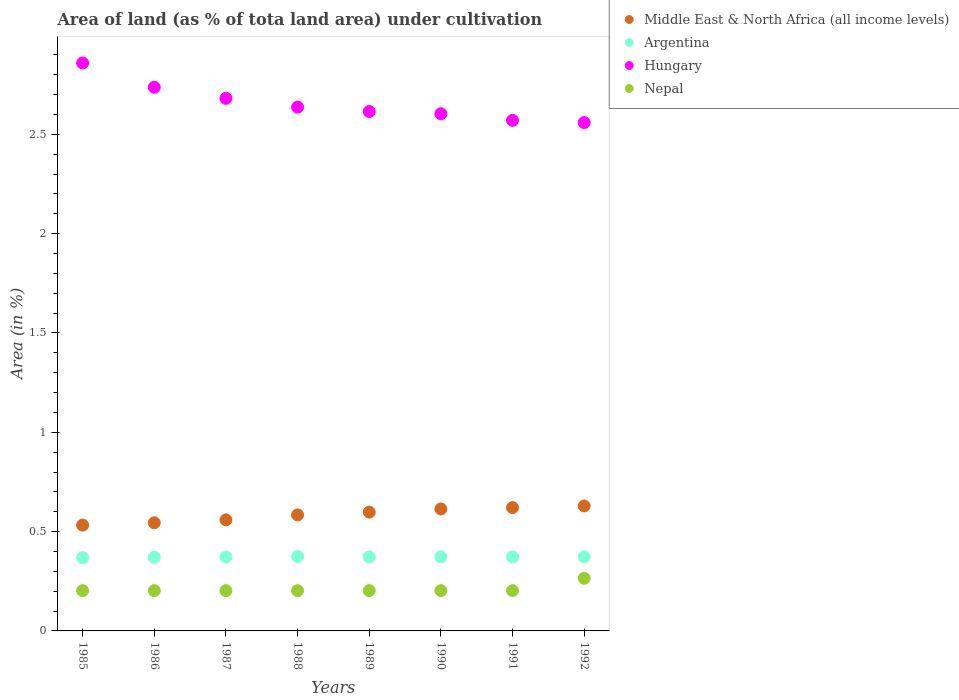Is the number of dotlines equal to the number of legend labels?
Provide a succinct answer. Yes. What is the percentage of land under cultivation in Middle East & North Africa (all income levels) in 1986?
Offer a terse response. 0.54. Across all years, what is the maximum percentage of land under cultivation in Hungary?
Keep it short and to the point. 2.86. Across all years, what is the minimum percentage of land under cultivation in Nepal?
Provide a succinct answer. 0.2. What is the total percentage of land under cultivation in Middle East & North Africa (all income levels) in the graph?
Ensure brevity in your answer.  4.68. What is the difference between the percentage of land under cultivation in Argentina in 1986 and that in 1987?
Offer a very short reply. -0. What is the difference between the percentage of land under cultivation in Nepal in 1991 and the percentage of land under cultivation in Argentina in 1987?
Provide a succinct answer. -0.17. What is the average percentage of land under cultivation in Hungary per year?
Make the answer very short. 2.66. In the year 1990, what is the difference between the percentage of land under cultivation in Nepal and percentage of land under cultivation in Argentina?
Provide a succinct answer. -0.17. In how many years, is the percentage of land under cultivation in Middle East & North Africa (all income levels) greater than 2.2 %?
Give a very brief answer. 0. What is the difference between the highest and the second highest percentage of land under cultivation in Hungary?
Give a very brief answer. 0.12. What is the difference between the highest and the lowest percentage of land under cultivation in Argentina?
Offer a terse response. 0.01. Does the percentage of land under cultivation in Nepal monotonically increase over the years?
Your answer should be very brief. No. Is the percentage of land under cultivation in Argentina strictly greater than the percentage of land under cultivation in Hungary over the years?
Offer a very short reply. No. How many dotlines are there?
Offer a very short reply. 4. How many years are there in the graph?
Your response must be concise. 8. Are the values on the major ticks of Y-axis written in scientific E-notation?
Your response must be concise. No. Does the graph contain any zero values?
Provide a succinct answer. No. How many legend labels are there?
Your response must be concise. 4. What is the title of the graph?
Your answer should be compact. Area of land (as % of tota land area) under cultivation. What is the label or title of the Y-axis?
Give a very brief answer. Area (in %). What is the Area (in %) in Middle East & North Africa (all income levels) in 1985?
Give a very brief answer. 0.53. What is the Area (in %) in Argentina in 1985?
Provide a succinct answer. 0.37. What is the Area (in %) in Hungary in 1985?
Your answer should be compact. 2.86. What is the Area (in %) in Nepal in 1985?
Provide a succinct answer. 0.2. What is the Area (in %) of Middle East & North Africa (all income levels) in 1986?
Your answer should be compact. 0.54. What is the Area (in %) in Argentina in 1986?
Offer a very short reply. 0.37. What is the Area (in %) in Hungary in 1986?
Provide a succinct answer. 2.74. What is the Area (in %) in Nepal in 1986?
Your answer should be very brief. 0.2. What is the Area (in %) in Middle East & North Africa (all income levels) in 1987?
Ensure brevity in your answer.  0.56. What is the Area (in %) of Argentina in 1987?
Ensure brevity in your answer.  0.37. What is the Area (in %) in Hungary in 1987?
Give a very brief answer. 2.68. What is the Area (in %) of Nepal in 1987?
Your answer should be very brief. 0.2. What is the Area (in %) of Middle East & North Africa (all income levels) in 1988?
Your answer should be compact. 0.58. What is the Area (in %) in Argentina in 1988?
Make the answer very short. 0.37. What is the Area (in %) in Hungary in 1988?
Offer a terse response. 2.64. What is the Area (in %) in Nepal in 1988?
Provide a short and direct response. 0.2. What is the Area (in %) in Middle East & North Africa (all income levels) in 1989?
Offer a very short reply. 0.6. What is the Area (in %) of Argentina in 1989?
Your answer should be very brief. 0.37. What is the Area (in %) of Hungary in 1989?
Your answer should be compact. 2.61. What is the Area (in %) in Nepal in 1989?
Offer a terse response. 0.2. What is the Area (in %) in Middle East & North Africa (all income levels) in 1990?
Keep it short and to the point. 0.61. What is the Area (in %) of Argentina in 1990?
Ensure brevity in your answer.  0.37. What is the Area (in %) of Hungary in 1990?
Your answer should be very brief. 2.6. What is the Area (in %) in Nepal in 1990?
Offer a terse response. 0.2. What is the Area (in %) in Middle East & North Africa (all income levels) in 1991?
Offer a very short reply. 0.62. What is the Area (in %) in Argentina in 1991?
Offer a very short reply. 0.37. What is the Area (in %) of Hungary in 1991?
Your answer should be very brief. 2.57. What is the Area (in %) of Nepal in 1991?
Ensure brevity in your answer.  0.2. What is the Area (in %) of Middle East & North Africa (all income levels) in 1992?
Offer a very short reply. 0.63. What is the Area (in %) in Argentina in 1992?
Provide a succinct answer. 0.37. What is the Area (in %) of Hungary in 1992?
Your answer should be very brief. 2.56. What is the Area (in %) in Nepal in 1992?
Give a very brief answer. 0.27. Across all years, what is the maximum Area (in %) of Middle East & North Africa (all income levels)?
Offer a terse response. 0.63. Across all years, what is the maximum Area (in %) in Argentina?
Your response must be concise. 0.37. Across all years, what is the maximum Area (in %) in Hungary?
Your answer should be compact. 2.86. Across all years, what is the maximum Area (in %) in Nepal?
Your response must be concise. 0.27. Across all years, what is the minimum Area (in %) of Middle East & North Africa (all income levels)?
Ensure brevity in your answer.  0.53. Across all years, what is the minimum Area (in %) in Argentina?
Your answer should be compact. 0.37. Across all years, what is the minimum Area (in %) of Hungary?
Provide a short and direct response. 2.56. Across all years, what is the minimum Area (in %) of Nepal?
Your answer should be compact. 0.2. What is the total Area (in %) of Middle East & North Africa (all income levels) in the graph?
Your answer should be compact. 4.68. What is the total Area (in %) of Argentina in the graph?
Offer a terse response. 2.98. What is the total Area (in %) of Hungary in the graph?
Keep it short and to the point. 21.26. What is the total Area (in %) of Nepal in the graph?
Give a very brief answer. 1.68. What is the difference between the Area (in %) of Middle East & North Africa (all income levels) in 1985 and that in 1986?
Offer a terse response. -0.01. What is the difference between the Area (in %) of Argentina in 1985 and that in 1986?
Your answer should be compact. -0. What is the difference between the Area (in %) in Hungary in 1985 and that in 1986?
Make the answer very short. 0.12. What is the difference between the Area (in %) of Nepal in 1985 and that in 1986?
Offer a terse response. 0. What is the difference between the Area (in %) of Middle East & North Africa (all income levels) in 1985 and that in 1987?
Provide a short and direct response. -0.03. What is the difference between the Area (in %) of Argentina in 1985 and that in 1987?
Provide a succinct answer. -0. What is the difference between the Area (in %) of Hungary in 1985 and that in 1987?
Give a very brief answer. 0.18. What is the difference between the Area (in %) of Nepal in 1985 and that in 1987?
Your answer should be very brief. 0. What is the difference between the Area (in %) in Middle East & North Africa (all income levels) in 1985 and that in 1988?
Make the answer very short. -0.05. What is the difference between the Area (in %) of Argentina in 1985 and that in 1988?
Provide a short and direct response. -0.01. What is the difference between the Area (in %) in Hungary in 1985 and that in 1988?
Your response must be concise. 0.22. What is the difference between the Area (in %) in Middle East & North Africa (all income levels) in 1985 and that in 1989?
Give a very brief answer. -0.07. What is the difference between the Area (in %) of Argentina in 1985 and that in 1989?
Offer a terse response. -0. What is the difference between the Area (in %) in Hungary in 1985 and that in 1989?
Your response must be concise. 0.24. What is the difference between the Area (in %) in Nepal in 1985 and that in 1989?
Provide a succinct answer. 0. What is the difference between the Area (in %) of Middle East & North Africa (all income levels) in 1985 and that in 1990?
Your answer should be compact. -0.08. What is the difference between the Area (in %) of Argentina in 1985 and that in 1990?
Your answer should be compact. -0. What is the difference between the Area (in %) in Hungary in 1985 and that in 1990?
Offer a terse response. 0.26. What is the difference between the Area (in %) of Nepal in 1985 and that in 1990?
Make the answer very short. 0. What is the difference between the Area (in %) in Middle East & North Africa (all income levels) in 1985 and that in 1991?
Provide a succinct answer. -0.09. What is the difference between the Area (in %) in Argentina in 1985 and that in 1991?
Offer a very short reply. -0. What is the difference between the Area (in %) in Hungary in 1985 and that in 1991?
Your answer should be very brief. 0.29. What is the difference between the Area (in %) of Nepal in 1985 and that in 1991?
Give a very brief answer. 0. What is the difference between the Area (in %) of Middle East & North Africa (all income levels) in 1985 and that in 1992?
Keep it short and to the point. -0.1. What is the difference between the Area (in %) of Argentina in 1985 and that in 1992?
Give a very brief answer. -0. What is the difference between the Area (in %) in Hungary in 1985 and that in 1992?
Give a very brief answer. 0.3. What is the difference between the Area (in %) of Nepal in 1985 and that in 1992?
Your answer should be compact. -0.06. What is the difference between the Area (in %) in Middle East & North Africa (all income levels) in 1986 and that in 1987?
Make the answer very short. -0.01. What is the difference between the Area (in %) in Argentina in 1986 and that in 1987?
Ensure brevity in your answer.  -0. What is the difference between the Area (in %) in Hungary in 1986 and that in 1987?
Your response must be concise. 0.06. What is the difference between the Area (in %) in Nepal in 1986 and that in 1987?
Offer a very short reply. 0. What is the difference between the Area (in %) in Middle East & North Africa (all income levels) in 1986 and that in 1988?
Ensure brevity in your answer.  -0.04. What is the difference between the Area (in %) of Argentina in 1986 and that in 1988?
Your answer should be compact. -0. What is the difference between the Area (in %) of Hungary in 1986 and that in 1988?
Offer a very short reply. 0.1. What is the difference between the Area (in %) in Nepal in 1986 and that in 1988?
Make the answer very short. 0. What is the difference between the Area (in %) of Middle East & North Africa (all income levels) in 1986 and that in 1989?
Ensure brevity in your answer.  -0.05. What is the difference between the Area (in %) in Argentina in 1986 and that in 1989?
Keep it short and to the point. -0. What is the difference between the Area (in %) in Hungary in 1986 and that in 1989?
Offer a very short reply. 0.12. What is the difference between the Area (in %) in Middle East & North Africa (all income levels) in 1986 and that in 1990?
Ensure brevity in your answer.  -0.07. What is the difference between the Area (in %) in Argentina in 1986 and that in 1990?
Your answer should be compact. -0. What is the difference between the Area (in %) in Hungary in 1986 and that in 1990?
Provide a short and direct response. 0.13. What is the difference between the Area (in %) of Middle East & North Africa (all income levels) in 1986 and that in 1991?
Offer a terse response. -0.08. What is the difference between the Area (in %) in Argentina in 1986 and that in 1991?
Offer a terse response. -0. What is the difference between the Area (in %) of Hungary in 1986 and that in 1991?
Give a very brief answer. 0.17. What is the difference between the Area (in %) of Middle East & North Africa (all income levels) in 1986 and that in 1992?
Offer a very short reply. -0.08. What is the difference between the Area (in %) of Argentina in 1986 and that in 1992?
Ensure brevity in your answer.  -0. What is the difference between the Area (in %) in Hungary in 1986 and that in 1992?
Provide a short and direct response. 0.18. What is the difference between the Area (in %) of Nepal in 1986 and that in 1992?
Your response must be concise. -0.06. What is the difference between the Area (in %) of Middle East & North Africa (all income levels) in 1987 and that in 1988?
Ensure brevity in your answer.  -0.02. What is the difference between the Area (in %) in Argentina in 1987 and that in 1988?
Make the answer very short. -0. What is the difference between the Area (in %) of Hungary in 1987 and that in 1988?
Provide a short and direct response. 0.04. What is the difference between the Area (in %) of Middle East & North Africa (all income levels) in 1987 and that in 1989?
Your answer should be compact. -0.04. What is the difference between the Area (in %) of Argentina in 1987 and that in 1989?
Offer a very short reply. -0. What is the difference between the Area (in %) in Hungary in 1987 and that in 1989?
Provide a short and direct response. 0.07. What is the difference between the Area (in %) of Middle East & North Africa (all income levels) in 1987 and that in 1990?
Offer a very short reply. -0.05. What is the difference between the Area (in %) of Argentina in 1987 and that in 1990?
Ensure brevity in your answer.  -0. What is the difference between the Area (in %) in Hungary in 1987 and that in 1990?
Ensure brevity in your answer.  0.08. What is the difference between the Area (in %) in Middle East & North Africa (all income levels) in 1987 and that in 1991?
Provide a short and direct response. -0.06. What is the difference between the Area (in %) of Argentina in 1987 and that in 1991?
Offer a terse response. -0. What is the difference between the Area (in %) of Hungary in 1987 and that in 1991?
Offer a very short reply. 0.11. What is the difference between the Area (in %) in Nepal in 1987 and that in 1991?
Ensure brevity in your answer.  0. What is the difference between the Area (in %) in Middle East & North Africa (all income levels) in 1987 and that in 1992?
Ensure brevity in your answer.  -0.07. What is the difference between the Area (in %) of Argentina in 1987 and that in 1992?
Provide a succinct answer. -0. What is the difference between the Area (in %) of Hungary in 1987 and that in 1992?
Keep it short and to the point. 0.12. What is the difference between the Area (in %) in Nepal in 1987 and that in 1992?
Your answer should be very brief. -0.06. What is the difference between the Area (in %) in Middle East & North Africa (all income levels) in 1988 and that in 1989?
Give a very brief answer. -0.01. What is the difference between the Area (in %) in Argentina in 1988 and that in 1989?
Make the answer very short. 0. What is the difference between the Area (in %) of Hungary in 1988 and that in 1989?
Make the answer very short. 0.02. What is the difference between the Area (in %) of Nepal in 1988 and that in 1989?
Provide a short and direct response. 0. What is the difference between the Area (in %) of Middle East & North Africa (all income levels) in 1988 and that in 1990?
Your response must be concise. -0.03. What is the difference between the Area (in %) in Argentina in 1988 and that in 1990?
Your response must be concise. 0. What is the difference between the Area (in %) in Hungary in 1988 and that in 1990?
Make the answer very short. 0.03. What is the difference between the Area (in %) of Nepal in 1988 and that in 1990?
Your answer should be very brief. 0. What is the difference between the Area (in %) of Middle East & North Africa (all income levels) in 1988 and that in 1991?
Your answer should be compact. -0.04. What is the difference between the Area (in %) of Argentina in 1988 and that in 1991?
Ensure brevity in your answer.  0. What is the difference between the Area (in %) of Hungary in 1988 and that in 1991?
Your response must be concise. 0.07. What is the difference between the Area (in %) of Nepal in 1988 and that in 1991?
Provide a succinct answer. 0. What is the difference between the Area (in %) in Middle East & North Africa (all income levels) in 1988 and that in 1992?
Your answer should be very brief. -0.05. What is the difference between the Area (in %) in Argentina in 1988 and that in 1992?
Offer a very short reply. 0. What is the difference between the Area (in %) of Hungary in 1988 and that in 1992?
Keep it short and to the point. 0.08. What is the difference between the Area (in %) of Nepal in 1988 and that in 1992?
Your answer should be compact. -0.06. What is the difference between the Area (in %) of Middle East & North Africa (all income levels) in 1989 and that in 1990?
Your response must be concise. -0.02. What is the difference between the Area (in %) in Argentina in 1989 and that in 1990?
Make the answer very short. 0. What is the difference between the Area (in %) in Hungary in 1989 and that in 1990?
Offer a terse response. 0.01. What is the difference between the Area (in %) of Nepal in 1989 and that in 1990?
Make the answer very short. 0. What is the difference between the Area (in %) in Middle East & North Africa (all income levels) in 1989 and that in 1991?
Give a very brief answer. -0.02. What is the difference between the Area (in %) of Hungary in 1989 and that in 1991?
Make the answer very short. 0.04. What is the difference between the Area (in %) of Middle East & North Africa (all income levels) in 1989 and that in 1992?
Your answer should be compact. -0.03. What is the difference between the Area (in %) of Hungary in 1989 and that in 1992?
Ensure brevity in your answer.  0.06. What is the difference between the Area (in %) of Nepal in 1989 and that in 1992?
Offer a terse response. -0.06. What is the difference between the Area (in %) in Middle East & North Africa (all income levels) in 1990 and that in 1991?
Ensure brevity in your answer.  -0.01. What is the difference between the Area (in %) of Hungary in 1990 and that in 1991?
Your response must be concise. 0.03. What is the difference between the Area (in %) in Nepal in 1990 and that in 1991?
Ensure brevity in your answer.  0. What is the difference between the Area (in %) in Middle East & North Africa (all income levels) in 1990 and that in 1992?
Ensure brevity in your answer.  -0.02. What is the difference between the Area (in %) of Argentina in 1990 and that in 1992?
Offer a very short reply. 0. What is the difference between the Area (in %) of Hungary in 1990 and that in 1992?
Provide a short and direct response. 0.04. What is the difference between the Area (in %) of Nepal in 1990 and that in 1992?
Your answer should be very brief. -0.06. What is the difference between the Area (in %) of Middle East & North Africa (all income levels) in 1991 and that in 1992?
Your answer should be compact. -0.01. What is the difference between the Area (in %) of Argentina in 1991 and that in 1992?
Your response must be concise. 0. What is the difference between the Area (in %) in Hungary in 1991 and that in 1992?
Provide a succinct answer. 0.01. What is the difference between the Area (in %) in Nepal in 1991 and that in 1992?
Give a very brief answer. -0.06. What is the difference between the Area (in %) of Middle East & North Africa (all income levels) in 1985 and the Area (in %) of Argentina in 1986?
Ensure brevity in your answer.  0.16. What is the difference between the Area (in %) of Middle East & North Africa (all income levels) in 1985 and the Area (in %) of Hungary in 1986?
Ensure brevity in your answer.  -2.2. What is the difference between the Area (in %) in Middle East & North Africa (all income levels) in 1985 and the Area (in %) in Nepal in 1986?
Offer a very short reply. 0.33. What is the difference between the Area (in %) of Argentina in 1985 and the Area (in %) of Hungary in 1986?
Offer a very short reply. -2.37. What is the difference between the Area (in %) of Argentina in 1985 and the Area (in %) of Nepal in 1986?
Your answer should be very brief. 0.17. What is the difference between the Area (in %) in Hungary in 1985 and the Area (in %) in Nepal in 1986?
Give a very brief answer. 2.66. What is the difference between the Area (in %) in Middle East & North Africa (all income levels) in 1985 and the Area (in %) in Argentina in 1987?
Provide a succinct answer. 0.16. What is the difference between the Area (in %) in Middle East & North Africa (all income levels) in 1985 and the Area (in %) in Hungary in 1987?
Make the answer very short. -2.15. What is the difference between the Area (in %) of Middle East & North Africa (all income levels) in 1985 and the Area (in %) of Nepal in 1987?
Make the answer very short. 0.33. What is the difference between the Area (in %) of Argentina in 1985 and the Area (in %) of Hungary in 1987?
Provide a succinct answer. -2.31. What is the difference between the Area (in %) of Argentina in 1985 and the Area (in %) of Nepal in 1987?
Offer a very short reply. 0.17. What is the difference between the Area (in %) in Hungary in 1985 and the Area (in %) in Nepal in 1987?
Provide a succinct answer. 2.66. What is the difference between the Area (in %) in Middle East & North Africa (all income levels) in 1985 and the Area (in %) in Argentina in 1988?
Make the answer very short. 0.16. What is the difference between the Area (in %) of Middle East & North Africa (all income levels) in 1985 and the Area (in %) of Hungary in 1988?
Your answer should be compact. -2.1. What is the difference between the Area (in %) of Middle East & North Africa (all income levels) in 1985 and the Area (in %) of Nepal in 1988?
Your response must be concise. 0.33. What is the difference between the Area (in %) in Argentina in 1985 and the Area (in %) in Hungary in 1988?
Make the answer very short. -2.27. What is the difference between the Area (in %) in Argentina in 1985 and the Area (in %) in Nepal in 1988?
Provide a short and direct response. 0.17. What is the difference between the Area (in %) in Hungary in 1985 and the Area (in %) in Nepal in 1988?
Keep it short and to the point. 2.66. What is the difference between the Area (in %) in Middle East & North Africa (all income levels) in 1985 and the Area (in %) in Argentina in 1989?
Make the answer very short. 0.16. What is the difference between the Area (in %) in Middle East & North Africa (all income levels) in 1985 and the Area (in %) in Hungary in 1989?
Keep it short and to the point. -2.08. What is the difference between the Area (in %) in Middle East & North Africa (all income levels) in 1985 and the Area (in %) in Nepal in 1989?
Offer a terse response. 0.33. What is the difference between the Area (in %) of Argentina in 1985 and the Area (in %) of Hungary in 1989?
Ensure brevity in your answer.  -2.25. What is the difference between the Area (in %) in Argentina in 1985 and the Area (in %) in Nepal in 1989?
Make the answer very short. 0.17. What is the difference between the Area (in %) in Hungary in 1985 and the Area (in %) in Nepal in 1989?
Keep it short and to the point. 2.66. What is the difference between the Area (in %) in Middle East & North Africa (all income levels) in 1985 and the Area (in %) in Argentina in 1990?
Your answer should be compact. 0.16. What is the difference between the Area (in %) in Middle East & North Africa (all income levels) in 1985 and the Area (in %) in Hungary in 1990?
Provide a succinct answer. -2.07. What is the difference between the Area (in %) in Middle East & North Africa (all income levels) in 1985 and the Area (in %) in Nepal in 1990?
Provide a short and direct response. 0.33. What is the difference between the Area (in %) of Argentina in 1985 and the Area (in %) of Hungary in 1990?
Keep it short and to the point. -2.24. What is the difference between the Area (in %) of Argentina in 1985 and the Area (in %) of Nepal in 1990?
Provide a short and direct response. 0.17. What is the difference between the Area (in %) of Hungary in 1985 and the Area (in %) of Nepal in 1990?
Your answer should be compact. 2.66. What is the difference between the Area (in %) in Middle East & North Africa (all income levels) in 1985 and the Area (in %) in Argentina in 1991?
Provide a succinct answer. 0.16. What is the difference between the Area (in %) in Middle East & North Africa (all income levels) in 1985 and the Area (in %) in Hungary in 1991?
Ensure brevity in your answer.  -2.04. What is the difference between the Area (in %) of Middle East & North Africa (all income levels) in 1985 and the Area (in %) of Nepal in 1991?
Make the answer very short. 0.33. What is the difference between the Area (in %) in Argentina in 1985 and the Area (in %) in Hungary in 1991?
Keep it short and to the point. -2.2. What is the difference between the Area (in %) in Argentina in 1985 and the Area (in %) in Nepal in 1991?
Your answer should be compact. 0.17. What is the difference between the Area (in %) of Hungary in 1985 and the Area (in %) of Nepal in 1991?
Your answer should be very brief. 2.66. What is the difference between the Area (in %) of Middle East & North Africa (all income levels) in 1985 and the Area (in %) of Argentina in 1992?
Ensure brevity in your answer.  0.16. What is the difference between the Area (in %) of Middle East & North Africa (all income levels) in 1985 and the Area (in %) of Hungary in 1992?
Ensure brevity in your answer.  -2.03. What is the difference between the Area (in %) in Middle East & North Africa (all income levels) in 1985 and the Area (in %) in Nepal in 1992?
Your answer should be compact. 0.27. What is the difference between the Area (in %) in Argentina in 1985 and the Area (in %) in Hungary in 1992?
Make the answer very short. -2.19. What is the difference between the Area (in %) of Argentina in 1985 and the Area (in %) of Nepal in 1992?
Your response must be concise. 0.1. What is the difference between the Area (in %) in Hungary in 1985 and the Area (in %) in Nepal in 1992?
Give a very brief answer. 2.59. What is the difference between the Area (in %) in Middle East & North Africa (all income levels) in 1986 and the Area (in %) in Argentina in 1987?
Your response must be concise. 0.17. What is the difference between the Area (in %) of Middle East & North Africa (all income levels) in 1986 and the Area (in %) of Hungary in 1987?
Your answer should be very brief. -2.14. What is the difference between the Area (in %) in Middle East & North Africa (all income levels) in 1986 and the Area (in %) in Nepal in 1987?
Give a very brief answer. 0.34. What is the difference between the Area (in %) in Argentina in 1986 and the Area (in %) in Hungary in 1987?
Offer a very short reply. -2.31. What is the difference between the Area (in %) in Argentina in 1986 and the Area (in %) in Nepal in 1987?
Offer a terse response. 0.17. What is the difference between the Area (in %) of Hungary in 1986 and the Area (in %) of Nepal in 1987?
Your answer should be compact. 2.53. What is the difference between the Area (in %) of Middle East & North Africa (all income levels) in 1986 and the Area (in %) of Argentina in 1988?
Your response must be concise. 0.17. What is the difference between the Area (in %) of Middle East & North Africa (all income levels) in 1986 and the Area (in %) of Hungary in 1988?
Keep it short and to the point. -2.09. What is the difference between the Area (in %) of Middle East & North Africa (all income levels) in 1986 and the Area (in %) of Nepal in 1988?
Provide a short and direct response. 0.34. What is the difference between the Area (in %) in Argentina in 1986 and the Area (in %) in Hungary in 1988?
Provide a succinct answer. -2.27. What is the difference between the Area (in %) in Argentina in 1986 and the Area (in %) in Nepal in 1988?
Your answer should be very brief. 0.17. What is the difference between the Area (in %) of Hungary in 1986 and the Area (in %) of Nepal in 1988?
Keep it short and to the point. 2.53. What is the difference between the Area (in %) in Middle East & North Africa (all income levels) in 1986 and the Area (in %) in Argentina in 1989?
Provide a short and direct response. 0.17. What is the difference between the Area (in %) in Middle East & North Africa (all income levels) in 1986 and the Area (in %) in Hungary in 1989?
Make the answer very short. -2.07. What is the difference between the Area (in %) of Middle East & North Africa (all income levels) in 1986 and the Area (in %) of Nepal in 1989?
Make the answer very short. 0.34. What is the difference between the Area (in %) in Argentina in 1986 and the Area (in %) in Hungary in 1989?
Your answer should be very brief. -2.24. What is the difference between the Area (in %) of Argentina in 1986 and the Area (in %) of Nepal in 1989?
Your answer should be very brief. 0.17. What is the difference between the Area (in %) in Hungary in 1986 and the Area (in %) in Nepal in 1989?
Your answer should be very brief. 2.53. What is the difference between the Area (in %) in Middle East & North Africa (all income levels) in 1986 and the Area (in %) in Argentina in 1990?
Provide a short and direct response. 0.17. What is the difference between the Area (in %) of Middle East & North Africa (all income levels) in 1986 and the Area (in %) of Hungary in 1990?
Make the answer very short. -2.06. What is the difference between the Area (in %) of Middle East & North Africa (all income levels) in 1986 and the Area (in %) of Nepal in 1990?
Provide a succinct answer. 0.34. What is the difference between the Area (in %) in Argentina in 1986 and the Area (in %) in Hungary in 1990?
Your answer should be very brief. -2.23. What is the difference between the Area (in %) in Argentina in 1986 and the Area (in %) in Nepal in 1990?
Your answer should be compact. 0.17. What is the difference between the Area (in %) in Hungary in 1986 and the Area (in %) in Nepal in 1990?
Ensure brevity in your answer.  2.53. What is the difference between the Area (in %) in Middle East & North Africa (all income levels) in 1986 and the Area (in %) in Argentina in 1991?
Offer a very short reply. 0.17. What is the difference between the Area (in %) of Middle East & North Africa (all income levels) in 1986 and the Area (in %) of Hungary in 1991?
Provide a succinct answer. -2.03. What is the difference between the Area (in %) in Middle East & North Africa (all income levels) in 1986 and the Area (in %) in Nepal in 1991?
Provide a succinct answer. 0.34. What is the difference between the Area (in %) of Argentina in 1986 and the Area (in %) of Hungary in 1991?
Your answer should be compact. -2.2. What is the difference between the Area (in %) in Argentina in 1986 and the Area (in %) in Nepal in 1991?
Your answer should be very brief. 0.17. What is the difference between the Area (in %) of Hungary in 1986 and the Area (in %) of Nepal in 1991?
Make the answer very short. 2.53. What is the difference between the Area (in %) of Middle East & North Africa (all income levels) in 1986 and the Area (in %) of Argentina in 1992?
Ensure brevity in your answer.  0.17. What is the difference between the Area (in %) in Middle East & North Africa (all income levels) in 1986 and the Area (in %) in Hungary in 1992?
Keep it short and to the point. -2.01. What is the difference between the Area (in %) in Middle East & North Africa (all income levels) in 1986 and the Area (in %) in Nepal in 1992?
Provide a short and direct response. 0.28. What is the difference between the Area (in %) in Argentina in 1986 and the Area (in %) in Hungary in 1992?
Give a very brief answer. -2.19. What is the difference between the Area (in %) in Argentina in 1986 and the Area (in %) in Nepal in 1992?
Provide a succinct answer. 0.11. What is the difference between the Area (in %) in Hungary in 1986 and the Area (in %) in Nepal in 1992?
Provide a short and direct response. 2.47. What is the difference between the Area (in %) in Middle East & North Africa (all income levels) in 1987 and the Area (in %) in Argentina in 1988?
Provide a short and direct response. 0.18. What is the difference between the Area (in %) in Middle East & North Africa (all income levels) in 1987 and the Area (in %) in Hungary in 1988?
Give a very brief answer. -2.08. What is the difference between the Area (in %) in Middle East & North Africa (all income levels) in 1987 and the Area (in %) in Nepal in 1988?
Keep it short and to the point. 0.36. What is the difference between the Area (in %) of Argentina in 1987 and the Area (in %) of Hungary in 1988?
Keep it short and to the point. -2.26. What is the difference between the Area (in %) of Argentina in 1987 and the Area (in %) of Nepal in 1988?
Provide a short and direct response. 0.17. What is the difference between the Area (in %) in Hungary in 1987 and the Area (in %) in Nepal in 1988?
Make the answer very short. 2.48. What is the difference between the Area (in %) in Middle East & North Africa (all income levels) in 1987 and the Area (in %) in Argentina in 1989?
Your answer should be very brief. 0.19. What is the difference between the Area (in %) in Middle East & North Africa (all income levels) in 1987 and the Area (in %) in Hungary in 1989?
Provide a short and direct response. -2.06. What is the difference between the Area (in %) of Middle East & North Africa (all income levels) in 1987 and the Area (in %) of Nepal in 1989?
Give a very brief answer. 0.36. What is the difference between the Area (in %) of Argentina in 1987 and the Area (in %) of Hungary in 1989?
Your response must be concise. -2.24. What is the difference between the Area (in %) of Argentina in 1987 and the Area (in %) of Nepal in 1989?
Provide a short and direct response. 0.17. What is the difference between the Area (in %) of Hungary in 1987 and the Area (in %) of Nepal in 1989?
Offer a very short reply. 2.48. What is the difference between the Area (in %) in Middle East & North Africa (all income levels) in 1987 and the Area (in %) in Argentina in 1990?
Offer a very short reply. 0.19. What is the difference between the Area (in %) of Middle East & North Africa (all income levels) in 1987 and the Area (in %) of Hungary in 1990?
Your answer should be very brief. -2.04. What is the difference between the Area (in %) in Middle East & North Africa (all income levels) in 1987 and the Area (in %) in Nepal in 1990?
Provide a succinct answer. 0.36. What is the difference between the Area (in %) in Argentina in 1987 and the Area (in %) in Hungary in 1990?
Provide a succinct answer. -2.23. What is the difference between the Area (in %) of Argentina in 1987 and the Area (in %) of Nepal in 1990?
Your answer should be very brief. 0.17. What is the difference between the Area (in %) in Hungary in 1987 and the Area (in %) in Nepal in 1990?
Your answer should be compact. 2.48. What is the difference between the Area (in %) in Middle East & North Africa (all income levels) in 1987 and the Area (in %) in Argentina in 1991?
Ensure brevity in your answer.  0.19. What is the difference between the Area (in %) in Middle East & North Africa (all income levels) in 1987 and the Area (in %) in Hungary in 1991?
Your answer should be very brief. -2.01. What is the difference between the Area (in %) of Middle East & North Africa (all income levels) in 1987 and the Area (in %) of Nepal in 1991?
Ensure brevity in your answer.  0.36. What is the difference between the Area (in %) in Argentina in 1987 and the Area (in %) in Hungary in 1991?
Make the answer very short. -2.2. What is the difference between the Area (in %) in Argentina in 1987 and the Area (in %) in Nepal in 1991?
Your answer should be very brief. 0.17. What is the difference between the Area (in %) in Hungary in 1987 and the Area (in %) in Nepal in 1991?
Your answer should be very brief. 2.48. What is the difference between the Area (in %) in Middle East & North Africa (all income levels) in 1987 and the Area (in %) in Argentina in 1992?
Your answer should be very brief. 0.19. What is the difference between the Area (in %) of Middle East & North Africa (all income levels) in 1987 and the Area (in %) of Hungary in 1992?
Make the answer very short. -2. What is the difference between the Area (in %) of Middle East & North Africa (all income levels) in 1987 and the Area (in %) of Nepal in 1992?
Ensure brevity in your answer.  0.29. What is the difference between the Area (in %) in Argentina in 1987 and the Area (in %) in Hungary in 1992?
Offer a very short reply. -2.19. What is the difference between the Area (in %) of Argentina in 1987 and the Area (in %) of Nepal in 1992?
Keep it short and to the point. 0.11. What is the difference between the Area (in %) in Hungary in 1987 and the Area (in %) in Nepal in 1992?
Offer a terse response. 2.42. What is the difference between the Area (in %) of Middle East & North Africa (all income levels) in 1988 and the Area (in %) of Argentina in 1989?
Your answer should be very brief. 0.21. What is the difference between the Area (in %) of Middle East & North Africa (all income levels) in 1988 and the Area (in %) of Hungary in 1989?
Your answer should be compact. -2.03. What is the difference between the Area (in %) of Middle East & North Africa (all income levels) in 1988 and the Area (in %) of Nepal in 1989?
Offer a terse response. 0.38. What is the difference between the Area (in %) in Argentina in 1988 and the Area (in %) in Hungary in 1989?
Ensure brevity in your answer.  -2.24. What is the difference between the Area (in %) in Argentina in 1988 and the Area (in %) in Nepal in 1989?
Provide a succinct answer. 0.17. What is the difference between the Area (in %) in Hungary in 1988 and the Area (in %) in Nepal in 1989?
Your answer should be compact. 2.43. What is the difference between the Area (in %) in Middle East & North Africa (all income levels) in 1988 and the Area (in %) in Argentina in 1990?
Ensure brevity in your answer.  0.21. What is the difference between the Area (in %) of Middle East & North Africa (all income levels) in 1988 and the Area (in %) of Hungary in 1990?
Your answer should be compact. -2.02. What is the difference between the Area (in %) in Middle East & North Africa (all income levels) in 1988 and the Area (in %) in Nepal in 1990?
Provide a succinct answer. 0.38. What is the difference between the Area (in %) in Argentina in 1988 and the Area (in %) in Hungary in 1990?
Provide a short and direct response. -2.23. What is the difference between the Area (in %) of Argentina in 1988 and the Area (in %) of Nepal in 1990?
Make the answer very short. 0.17. What is the difference between the Area (in %) in Hungary in 1988 and the Area (in %) in Nepal in 1990?
Keep it short and to the point. 2.43. What is the difference between the Area (in %) in Middle East & North Africa (all income levels) in 1988 and the Area (in %) in Argentina in 1991?
Your answer should be very brief. 0.21. What is the difference between the Area (in %) of Middle East & North Africa (all income levels) in 1988 and the Area (in %) of Hungary in 1991?
Provide a short and direct response. -1.99. What is the difference between the Area (in %) of Middle East & North Africa (all income levels) in 1988 and the Area (in %) of Nepal in 1991?
Make the answer very short. 0.38. What is the difference between the Area (in %) of Argentina in 1988 and the Area (in %) of Hungary in 1991?
Give a very brief answer. -2.2. What is the difference between the Area (in %) in Argentina in 1988 and the Area (in %) in Nepal in 1991?
Keep it short and to the point. 0.17. What is the difference between the Area (in %) in Hungary in 1988 and the Area (in %) in Nepal in 1991?
Your answer should be compact. 2.43. What is the difference between the Area (in %) of Middle East & North Africa (all income levels) in 1988 and the Area (in %) of Argentina in 1992?
Your answer should be compact. 0.21. What is the difference between the Area (in %) of Middle East & North Africa (all income levels) in 1988 and the Area (in %) of Hungary in 1992?
Your response must be concise. -1.98. What is the difference between the Area (in %) of Middle East & North Africa (all income levels) in 1988 and the Area (in %) of Nepal in 1992?
Keep it short and to the point. 0.32. What is the difference between the Area (in %) of Argentina in 1988 and the Area (in %) of Hungary in 1992?
Offer a terse response. -2.18. What is the difference between the Area (in %) in Argentina in 1988 and the Area (in %) in Nepal in 1992?
Ensure brevity in your answer.  0.11. What is the difference between the Area (in %) of Hungary in 1988 and the Area (in %) of Nepal in 1992?
Your answer should be very brief. 2.37. What is the difference between the Area (in %) of Middle East & North Africa (all income levels) in 1989 and the Area (in %) of Argentina in 1990?
Give a very brief answer. 0.23. What is the difference between the Area (in %) of Middle East & North Africa (all income levels) in 1989 and the Area (in %) of Hungary in 1990?
Provide a short and direct response. -2.01. What is the difference between the Area (in %) of Middle East & North Africa (all income levels) in 1989 and the Area (in %) of Nepal in 1990?
Keep it short and to the point. 0.4. What is the difference between the Area (in %) of Argentina in 1989 and the Area (in %) of Hungary in 1990?
Keep it short and to the point. -2.23. What is the difference between the Area (in %) of Argentina in 1989 and the Area (in %) of Nepal in 1990?
Ensure brevity in your answer.  0.17. What is the difference between the Area (in %) of Hungary in 1989 and the Area (in %) of Nepal in 1990?
Provide a succinct answer. 2.41. What is the difference between the Area (in %) of Middle East & North Africa (all income levels) in 1989 and the Area (in %) of Argentina in 1991?
Your response must be concise. 0.23. What is the difference between the Area (in %) in Middle East & North Africa (all income levels) in 1989 and the Area (in %) in Hungary in 1991?
Offer a terse response. -1.97. What is the difference between the Area (in %) of Middle East & North Africa (all income levels) in 1989 and the Area (in %) of Nepal in 1991?
Make the answer very short. 0.4. What is the difference between the Area (in %) in Argentina in 1989 and the Area (in %) in Hungary in 1991?
Offer a very short reply. -2.2. What is the difference between the Area (in %) in Argentina in 1989 and the Area (in %) in Nepal in 1991?
Your answer should be compact. 0.17. What is the difference between the Area (in %) of Hungary in 1989 and the Area (in %) of Nepal in 1991?
Your answer should be compact. 2.41. What is the difference between the Area (in %) in Middle East & North Africa (all income levels) in 1989 and the Area (in %) in Argentina in 1992?
Offer a terse response. 0.23. What is the difference between the Area (in %) in Middle East & North Africa (all income levels) in 1989 and the Area (in %) in Hungary in 1992?
Provide a short and direct response. -1.96. What is the difference between the Area (in %) of Middle East & North Africa (all income levels) in 1989 and the Area (in %) of Nepal in 1992?
Offer a very short reply. 0.33. What is the difference between the Area (in %) of Argentina in 1989 and the Area (in %) of Hungary in 1992?
Ensure brevity in your answer.  -2.19. What is the difference between the Area (in %) in Argentina in 1989 and the Area (in %) in Nepal in 1992?
Keep it short and to the point. 0.11. What is the difference between the Area (in %) of Hungary in 1989 and the Area (in %) of Nepal in 1992?
Your answer should be very brief. 2.35. What is the difference between the Area (in %) in Middle East & North Africa (all income levels) in 1990 and the Area (in %) in Argentina in 1991?
Your response must be concise. 0.24. What is the difference between the Area (in %) of Middle East & North Africa (all income levels) in 1990 and the Area (in %) of Hungary in 1991?
Your response must be concise. -1.96. What is the difference between the Area (in %) of Middle East & North Africa (all income levels) in 1990 and the Area (in %) of Nepal in 1991?
Your answer should be very brief. 0.41. What is the difference between the Area (in %) in Argentina in 1990 and the Area (in %) in Hungary in 1991?
Make the answer very short. -2.2. What is the difference between the Area (in %) in Argentina in 1990 and the Area (in %) in Nepal in 1991?
Ensure brevity in your answer.  0.17. What is the difference between the Area (in %) in Hungary in 1990 and the Area (in %) in Nepal in 1991?
Your answer should be compact. 2.4. What is the difference between the Area (in %) in Middle East & North Africa (all income levels) in 1990 and the Area (in %) in Argentina in 1992?
Offer a very short reply. 0.24. What is the difference between the Area (in %) in Middle East & North Africa (all income levels) in 1990 and the Area (in %) in Hungary in 1992?
Make the answer very short. -1.95. What is the difference between the Area (in %) in Middle East & North Africa (all income levels) in 1990 and the Area (in %) in Nepal in 1992?
Give a very brief answer. 0.35. What is the difference between the Area (in %) in Argentina in 1990 and the Area (in %) in Hungary in 1992?
Offer a terse response. -2.19. What is the difference between the Area (in %) in Argentina in 1990 and the Area (in %) in Nepal in 1992?
Provide a short and direct response. 0.11. What is the difference between the Area (in %) of Hungary in 1990 and the Area (in %) of Nepal in 1992?
Your answer should be very brief. 2.34. What is the difference between the Area (in %) of Middle East & North Africa (all income levels) in 1991 and the Area (in %) of Argentina in 1992?
Your answer should be very brief. 0.25. What is the difference between the Area (in %) of Middle East & North Africa (all income levels) in 1991 and the Area (in %) of Hungary in 1992?
Your answer should be very brief. -1.94. What is the difference between the Area (in %) in Middle East & North Africa (all income levels) in 1991 and the Area (in %) in Nepal in 1992?
Your response must be concise. 0.36. What is the difference between the Area (in %) in Argentina in 1991 and the Area (in %) in Hungary in 1992?
Your answer should be compact. -2.19. What is the difference between the Area (in %) of Argentina in 1991 and the Area (in %) of Nepal in 1992?
Provide a short and direct response. 0.11. What is the difference between the Area (in %) in Hungary in 1991 and the Area (in %) in Nepal in 1992?
Keep it short and to the point. 2.31. What is the average Area (in %) in Middle East & North Africa (all income levels) per year?
Keep it short and to the point. 0.59. What is the average Area (in %) in Argentina per year?
Keep it short and to the point. 0.37. What is the average Area (in %) of Hungary per year?
Your answer should be very brief. 2.66. What is the average Area (in %) in Nepal per year?
Give a very brief answer. 0.21. In the year 1985, what is the difference between the Area (in %) in Middle East & North Africa (all income levels) and Area (in %) in Argentina?
Give a very brief answer. 0.16. In the year 1985, what is the difference between the Area (in %) in Middle East & North Africa (all income levels) and Area (in %) in Hungary?
Ensure brevity in your answer.  -2.33. In the year 1985, what is the difference between the Area (in %) of Middle East & North Africa (all income levels) and Area (in %) of Nepal?
Offer a very short reply. 0.33. In the year 1985, what is the difference between the Area (in %) of Argentina and Area (in %) of Hungary?
Offer a very short reply. -2.49. In the year 1985, what is the difference between the Area (in %) in Argentina and Area (in %) in Nepal?
Provide a succinct answer. 0.17. In the year 1985, what is the difference between the Area (in %) in Hungary and Area (in %) in Nepal?
Make the answer very short. 2.66. In the year 1986, what is the difference between the Area (in %) of Middle East & North Africa (all income levels) and Area (in %) of Argentina?
Provide a succinct answer. 0.17. In the year 1986, what is the difference between the Area (in %) of Middle East & North Africa (all income levels) and Area (in %) of Hungary?
Provide a short and direct response. -2.19. In the year 1986, what is the difference between the Area (in %) in Middle East & North Africa (all income levels) and Area (in %) in Nepal?
Ensure brevity in your answer.  0.34. In the year 1986, what is the difference between the Area (in %) in Argentina and Area (in %) in Hungary?
Ensure brevity in your answer.  -2.37. In the year 1986, what is the difference between the Area (in %) of Argentina and Area (in %) of Nepal?
Your response must be concise. 0.17. In the year 1986, what is the difference between the Area (in %) of Hungary and Area (in %) of Nepal?
Make the answer very short. 2.53. In the year 1987, what is the difference between the Area (in %) in Middle East & North Africa (all income levels) and Area (in %) in Argentina?
Offer a terse response. 0.19. In the year 1987, what is the difference between the Area (in %) in Middle East & North Africa (all income levels) and Area (in %) in Hungary?
Offer a very short reply. -2.12. In the year 1987, what is the difference between the Area (in %) in Middle East & North Africa (all income levels) and Area (in %) in Nepal?
Offer a terse response. 0.36. In the year 1987, what is the difference between the Area (in %) of Argentina and Area (in %) of Hungary?
Provide a succinct answer. -2.31. In the year 1987, what is the difference between the Area (in %) in Argentina and Area (in %) in Nepal?
Ensure brevity in your answer.  0.17. In the year 1987, what is the difference between the Area (in %) of Hungary and Area (in %) of Nepal?
Keep it short and to the point. 2.48. In the year 1988, what is the difference between the Area (in %) of Middle East & North Africa (all income levels) and Area (in %) of Argentina?
Keep it short and to the point. 0.21. In the year 1988, what is the difference between the Area (in %) in Middle East & North Africa (all income levels) and Area (in %) in Hungary?
Make the answer very short. -2.05. In the year 1988, what is the difference between the Area (in %) in Middle East & North Africa (all income levels) and Area (in %) in Nepal?
Offer a very short reply. 0.38. In the year 1988, what is the difference between the Area (in %) in Argentina and Area (in %) in Hungary?
Ensure brevity in your answer.  -2.26. In the year 1988, what is the difference between the Area (in %) of Argentina and Area (in %) of Nepal?
Your response must be concise. 0.17. In the year 1988, what is the difference between the Area (in %) of Hungary and Area (in %) of Nepal?
Provide a succinct answer. 2.43. In the year 1989, what is the difference between the Area (in %) in Middle East & North Africa (all income levels) and Area (in %) in Argentina?
Ensure brevity in your answer.  0.23. In the year 1989, what is the difference between the Area (in %) of Middle East & North Africa (all income levels) and Area (in %) of Hungary?
Your response must be concise. -2.02. In the year 1989, what is the difference between the Area (in %) in Middle East & North Africa (all income levels) and Area (in %) in Nepal?
Ensure brevity in your answer.  0.4. In the year 1989, what is the difference between the Area (in %) in Argentina and Area (in %) in Hungary?
Ensure brevity in your answer.  -2.24. In the year 1989, what is the difference between the Area (in %) of Argentina and Area (in %) of Nepal?
Provide a succinct answer. 0.17. In the year 1989, what is the difference between the Area (in %) in Hungary and Area (in %) in Nepal?
Keep it short and to the point. 2.41. In the year 1990, what is the difference between the Area (in %) of Middle East & North Africa (all income levels) and Area (in %) of Argentina?
Make the answer very short. 0.24. In the year 1990, what is the difference between the Area (in %) of Middle East & North Africa (all income levels) and Area (in %) of Hungary?
Offer a very short reply. -1.99. In the year 1990, what is the difference between the Area (in %) of Middle East & North Africa (all income levels) and Area (in %) of Nepal?
Keep it short and to the point. 0.41. In the year 1990, what is the difference between the Area (in %) of Argentina and Area (in %) of Hungary?
Your response must be concise. -2.23. In the year 1990, what is the difference between the Area (in %) of Argentina and Area (in %) of Nepal?
Your answer should be compact. 0.17. In the year 1990, what is the difference between the Area (in %) of Hungary and Area (in %) of Nepal?
Make the answer very short. 2.4. In the year 1991, what is the difference between the Area (in %) of Middle East & North Africa (all income levels) and Area (in %) of Argentina?
Your response must be concise. 0.25. In the year 1991, what is the difference between the Area (in %) in Middle East & North Africa (all income levels) and Area (in %) in Hungary?
Ensure brevity in your answer.  -1.95. In the year 1991, what is the difference between the Area (in %) of Middle East & North Africa (all income levels) and Area (in %) of Nepal?
Provide a short and direct response. 0.42. In the year 1991, what is the difference between the Area (in %) of Argentina and Area (in %) of Hungary?
Give a very brief answer. -2.2. In the year 1991, what is the difference between the Area (in %) in Argentina and Area (in %) in Nepal?
Provide a succinct answer. 0.17. In the year 1991, what is the difference between the Area (in %) of Hungary and Area (in %) of Nepal?
Your response must be concise. 2.37. In the year 1992, what is the difference between the Area (in %) of Middle East & North Africa (all income levels) and Area (in %) of Argentina?
Make the answer very short. 0.26. In the year 1992, what is the difference between the Area (in %) in Middle East & North Africa (all income levels) and Area (in %) in Hungary?
Offer a terse response. -1.93. In the year 1992, what is the difference between the Area (in %) in Middle East & North Africa (all income levels) and Area (in %) in Nepal?
Your answer should be very brief. 0.36. In the year 1992, what is the difference between the Area (in %) in Argentina and Area (in %) in Hungary?
Offer a terse response. -2.19. In the year 1992, what is the difference between the Area (in %) in Argentina and Area (in %) in Nepal?
Your response must be concise. 0.11. In the year 1992, what is the difference between the Area (in %) of Hungary and Area (in %) of Nepal?
Provide a short and direct response. 2.29. What is the ratio of the Area (in %) of Middle East & North Africa (all income levels) in 1985 to that in 1986?
Your response must be concise. 0.98. What is the ratio of the Area (in %) of Hungary in 1985 to that in 1986?
Keep it short and to the point. 1.04. What is the ratio of the Area (in %) of Nepal in 1985 to that in 1986?
Offer a terse response. 1. What is the ratio of the Area (in %) in Middle East & North Africa (all income levels) in 1985 to that in 1987?
Provide a succinct answer. 0.95. What is the ratio of the Area (in %) in Argentina in 1985 to that in 1987?
Your response must be concise. 0.99. What is the ratio of the Area (in %) of Hungary in 1985 to that in 1987?
Provide a short and direct response. 1.07. What is the ratio of the Area (in %) in Middle East & North Africa (all income levels) in 1985 to that in 1988?
Give a very brief answer. 0.91. What is the ratio of the Area (in %) of Argentina in 1985 to that in 1988?
Provide a short and direct response. 0.98. What is the ratio of the Area (in %) of Hungary in 1985 to that in 1988?
Your answer should be compact. 1.08. What is the ratio of the Area (in %) in Nepal in 1985 to that in 1988?
Offer a terse response. 1. What is the ratio of the Area (in %) of Middle East & North Africa (all income levels) in 1985 to that in 1989?
Keep it short and to the point. 0.89. What is the ratio of the Area (in %) of Hungary in 1985 to that in 1989?
Give a very brief answer. 1.09. What is the ratio of the Area (in %) of Nepal in 1985 to that in 1989?
Provide a succinct answer. 1. What is the ratio of the Area (in %) in Middle East & North Africa (all income levels) in 1985 to that in 1990?
Your answer should be very brief. 0.87. What is the ratio of the Area (in %) in Hungary in 1985 to that in 1990?
Your response must be concise. 1.1. What is the ratio of the Area (in %) in Middle East & North Africa (all income levels) in 1985 to that in 1991?
Ensure brevity in your answer.  0.86. What is the ratio of the Area (in %) of Argentina in 1985 to that in 1991?
Provide a short and direct response. 0.99. What is the ratio of the Area (in %) of Hungary in 1985 to that in 1991?
Make the answer very short. 1.11. What is the ratio of the Area (in %) of Middle East & North Africa (all income levels) in 1985 to that in 1992?
Make the answer very short. 0.85. What is the ratio of the Area (in %) in Hungary in 1985 to that in 1992?
Your response must be concise. 1.12. What is the ratio of the Area (in %) in Nepal in 1985 to that in 1992?
Make the answer very short. 0.77. What is the ratio of the Area (in %) in Middle East & North Africa (all income levels) in 1986 to that in 1987?
Keep it short and to the point. 0.97. What is the ratio of the Area (in %) in Hungary in 1986 to that in 1987?
Keep it short and to the point. 1.02. What is the ratio of the Area (in %) in Nepal in 1986 to that in 1987?
Provide a short and direct response. 1. What is the ratio of the Area (in %) of Middle East & North Africa (all income levels) in 1986 to that in 1988?
Your response must be concise. 0.93. What is the ratio of the Area (in %) in Argentina in 1986 to that in 1988?
Offer a very short reply. 0.99. What is the ratio of the Area (in %) in Hungary in 1986 to that in 1988?
Provide a short and direct response. 1.04. What is the ratio of the Area (in %) in Nepal in 1986 to that in 1988?
Offer a very short reply. 1. What is the ratio of the Area (in %) in Middle East & North Africa (all income levels) in 1986 to that in 1989?
Keep it short and to the point. 0.91. What is the ratio of the Area (in %) in Argentina in 1986 to that in 1989?
Your answer should be very brief. 0.99. What is the ratio of the Area (in %) of Hungary in 1986 to that in 1989?
Give a very brief answer. 1.05. What is the ratio of the Area (in %) of Middle East & North Africa (all income levels) in 1986 to that in 1990?
Offer a very short reply. 0.89. What is the ratio of the Area (in %) of Hungary in 1986 to that in 1990?
Offer a terse response. 1.05. What is the ratio of the Area (in %) of Nepal in 1986 to that in 1990?
Your response must be concise. 1. What is the ratio of the Area (in %) in Middle East & North Africa (all income levels) in 1986 to that in 1991?
Offer a very short reply. 0.88. What is the ratio of the Area (in %) in Hungary in 1986 to that in 1991?
Your answer should be very brief. 1.06. What is the ratio of the Area (in %) in Middle East & North Africa (all income levels) in 1986 to that in 1992?
Give a very brief answer. 0.87. What is the ratio of the Area (in %) in Argentina in 1986 to that in 1992?
Your response must be concise. 0.99. What is the ratio of the Area (in %) of Hungary in 1986 to that in 1992?
Your response must be concise. 1.07. What is the ratio of the Area (in %) in Nepal in 1986 to that in 1992?
Ensure brevity in your answer.  0.77. What is the ratio of the Area (in %) of Middle East & North Africa (all income levels) in 1987 to that in 1988?
Ensure brevity in your answer.  0.96. What is the ratio of the Area (in %) of Hungary in 1987 to that in 1988?
Provide a succinct answer. 1.02. What is the ratio of the Area (in %) in Nepal in 1987 to that in 1988?
Provide a succinct answer. 1. What is the ratio of the Area (in %) in Middle East & North Africa (all income levels) in 1987 to that in 1989?
Your answer should be compact. 0.93. What is the ratio of the Area (in %) in Argentina in 1987 to that in 1989?
Make the answer very short. 1. What is the ratio of the Area (in %) of Hungary in 1987 to that in 1989?
Your answer should be compact. 1.03. What is the ratio of the Area (in %) of Middle East & North Africa (all income levels) in 1987 to that in 1990?
Your answer should be compact. 0.91. What is the ratio of the Area (in %) in Hungary in 1987 to that in 1990?
Provide a short and direct response. 1.03. What is the ratio of the Area (in %) of Nepal in 1987 to that in 1990?
Provide a short and direct response. 1. What is the ratio of the Area (in %) of Middle East & North Africa (all income levels) in 1987 to that in 1991?
Keep it short and to the point. 0.9. What is the ratio of the Area (in %) of Hungary in 1987 to that in 1991?
Keep it short and to the point. 1.04. What is the ratio of the Area (in %) of Nepal in 1987 to that in 1991?
Provide a short and direct response. 1. What is the ratio of the Area (in %) of Middle East & North Africa (all income levels) in 1987 to that in 1992?
Your answer should be very brief. 0.89. What is the ratio of the Area (in %) of Hungary in 1987 to that in 1992?
Your answer should be very brief. 1.05. What is the ratio of the Area (in %) in Nepal in 1987 to that in 1992?
Your answer should be very brief. 0.77. What is the ratio of the Area (in %) of Middle East & North Africa (all income levels) in 1988 to that in 1989?
Give a very brief answer. 0.98. What is the ratio of the Area (in %) of Hungary in 1988 to that in 1989?
Give a very brief answer. 1.01. What is the ratio of the Area (in %) in Nepal in 1988 to that in 1989?
Offer a terse response. 1. What is the ratio of the Area (in %) of Middle East & North Africa (all income levels) in 1988 to that in 1990?
Offer a very short reply. 0.95. What is the ratio of the Area (in %) in Argentina in 1988 to that in 1990?
Offer a very short reply. 1. What is the ratio of the Area (in %) of Hungary in 1988 to that in 1990?
Make the answer very short. 1.01. What is the ratio of the Area (in %) of Middle East & North Africa (all income levels) in 1988 to that in 1991?
Ensure brevity in your answer.  0.94. What is the ratio of the Area (in %) in Argentina in 1988 to that in 1991?
Provide a succinct answer. 1. What is the ratio of the Area (in %) of Middle East & North Africa (all income levels) in 1988 to that in 1992?
Provide a succinct answer. 0.93. What is the ratio of the Area (in %) of Hungary in 1988 to that in 1992?
Offer a very short reply. 1.03. What is the ratio of the Area (in %) in Nepal in 1988 to that in 1992?
Give a very brief answer. 0.77. What is the ratio of the Area (in %) of Middle East & North Africa (all income levels) in 1989 to that in 1990?
Make the answer very short. 0.97. What is the ratio of the Area (in %) in Nepal in 1989 to that in 1990?
Your response must be concise. 1. What is the ratio of the Area (in %) of Middle East & North Africa (all income levels) in 1989 to that in 1991?
Give a very brief answer. 0.96. What is the ratio of the Area (in %) of Argentina in 1989 to that in 1991?
Your response must be concise. 1. What is the ratio of the Area (in %) of Hungary in 1989 to that in 1991?
Your response must be concise. 1.02. What is the ratio of the Area (in %) of Middle East & North Africa (all income levels) in 1989 to that in 1992?
Give a very brief answer. 0.95. What is the ratio of the Area (in %) in Argentina in 1989 to that in 1992?
Provide a succinct answer. 1. What is the ratio of the Area (in %) in Hungary in 1989 to that in 1992?
Your answer should be compact. 1.02. What is the ratio of the Area (in %) of Nepal in 1989 to that in 1992?
Provide a succinct answer. 0.77. What is the ratio of the Area (in %) of Argentina in 1990 to that in 1991?
Offer a terse response. 1. What is the ratio of the Area (in %) in Hungary in 1990 to that in 1991?
Provide a succinct answer. 1.01. What is the ratio of the Area (in %) in Middle East & North Africa (all income levels) in 1990 to that in 1992?
Offer a very short reply. 0.98. What is the ratio of the Area (in %) in Argentina in 1990 to that in 1992?
Make the answer very short. 1. What is the ratio of the Area (in %) of Hungary in 1990 to that in 1992?
Offer a terse response. 1.02. What is the ratio of the Area (in %) in Nepal in 1990 to that in 1992?
Give a very brief answer. 0.77. What is the ratio of the Area (in %) in Nepal in 1991 to that in 1992?
Your answer should be very brief. 0.77. What is the difference between the highest and the second highest Area (in %) of Middle East & North Africa (all income levels)?
Your response must be concise. 0.01. What is the difference between the highest and the second highest Area (in %) in Argentina?
Provide a succinct answer. 0. What is the difference between the highest and the second highest Area (in %) in Hungary?
Provide a succinct answer. 0.12. What is the difference between the highest and the second highest Area (in %) of Nepal?
Make the answer very short. 0.06. What is the difference between the highest and the lowest Area (in %) of Middle East & North Africa (all income levels)?
Offer a very short reply. 0.1. What is the difference between the highest and the lowest Area (in %) in Argentina?
Make the answer very short. 0.01. What is the difference between the highest and the lowest Area (in %) of Hungary?
Provide a succinct answer. 0.3. What is the difference between the highest and the lowest Area (in %) of Nepal?
Provide a succinct answer. 0.06. 